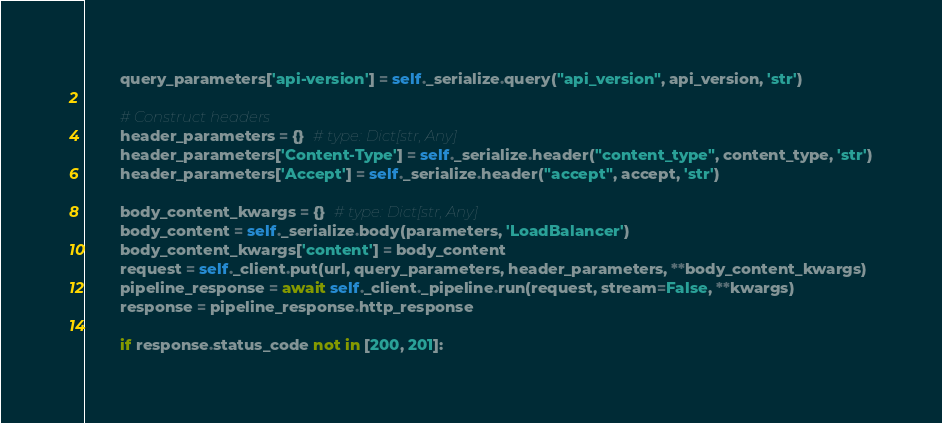Convert code to text. <code><loc_0><loc_0><loc_500><loc_500><_Python_>        query_parameters['api-version'] = self._serialize.query("api_version", api_version, 'str')

        # Construct headers
        header_parameters = {}  # type: Dict[str, Any]
        header_parameters['Content-Type'] = self._serialize.header("content_type", content_type, 'str')
        header_parameters['Accept'] = self._serialize.header("accept", accept, 'str')

        body_content_kwargs = {}  # type: Dict[str, Any]
        body_content = self._serialize.body(parameters, 'LoadBalancer')
        body_content_kwargs['content'] = body_content
        request = self._client.put(url, query_parameters, header_parameters, **body_content_kwargs)
        pipeline_response = await self._client._pipeline.run(request, stream=False, **kwargs)
        response = pipeline_response.http_response

        if response.status_code not in [200, 201]:</code> 